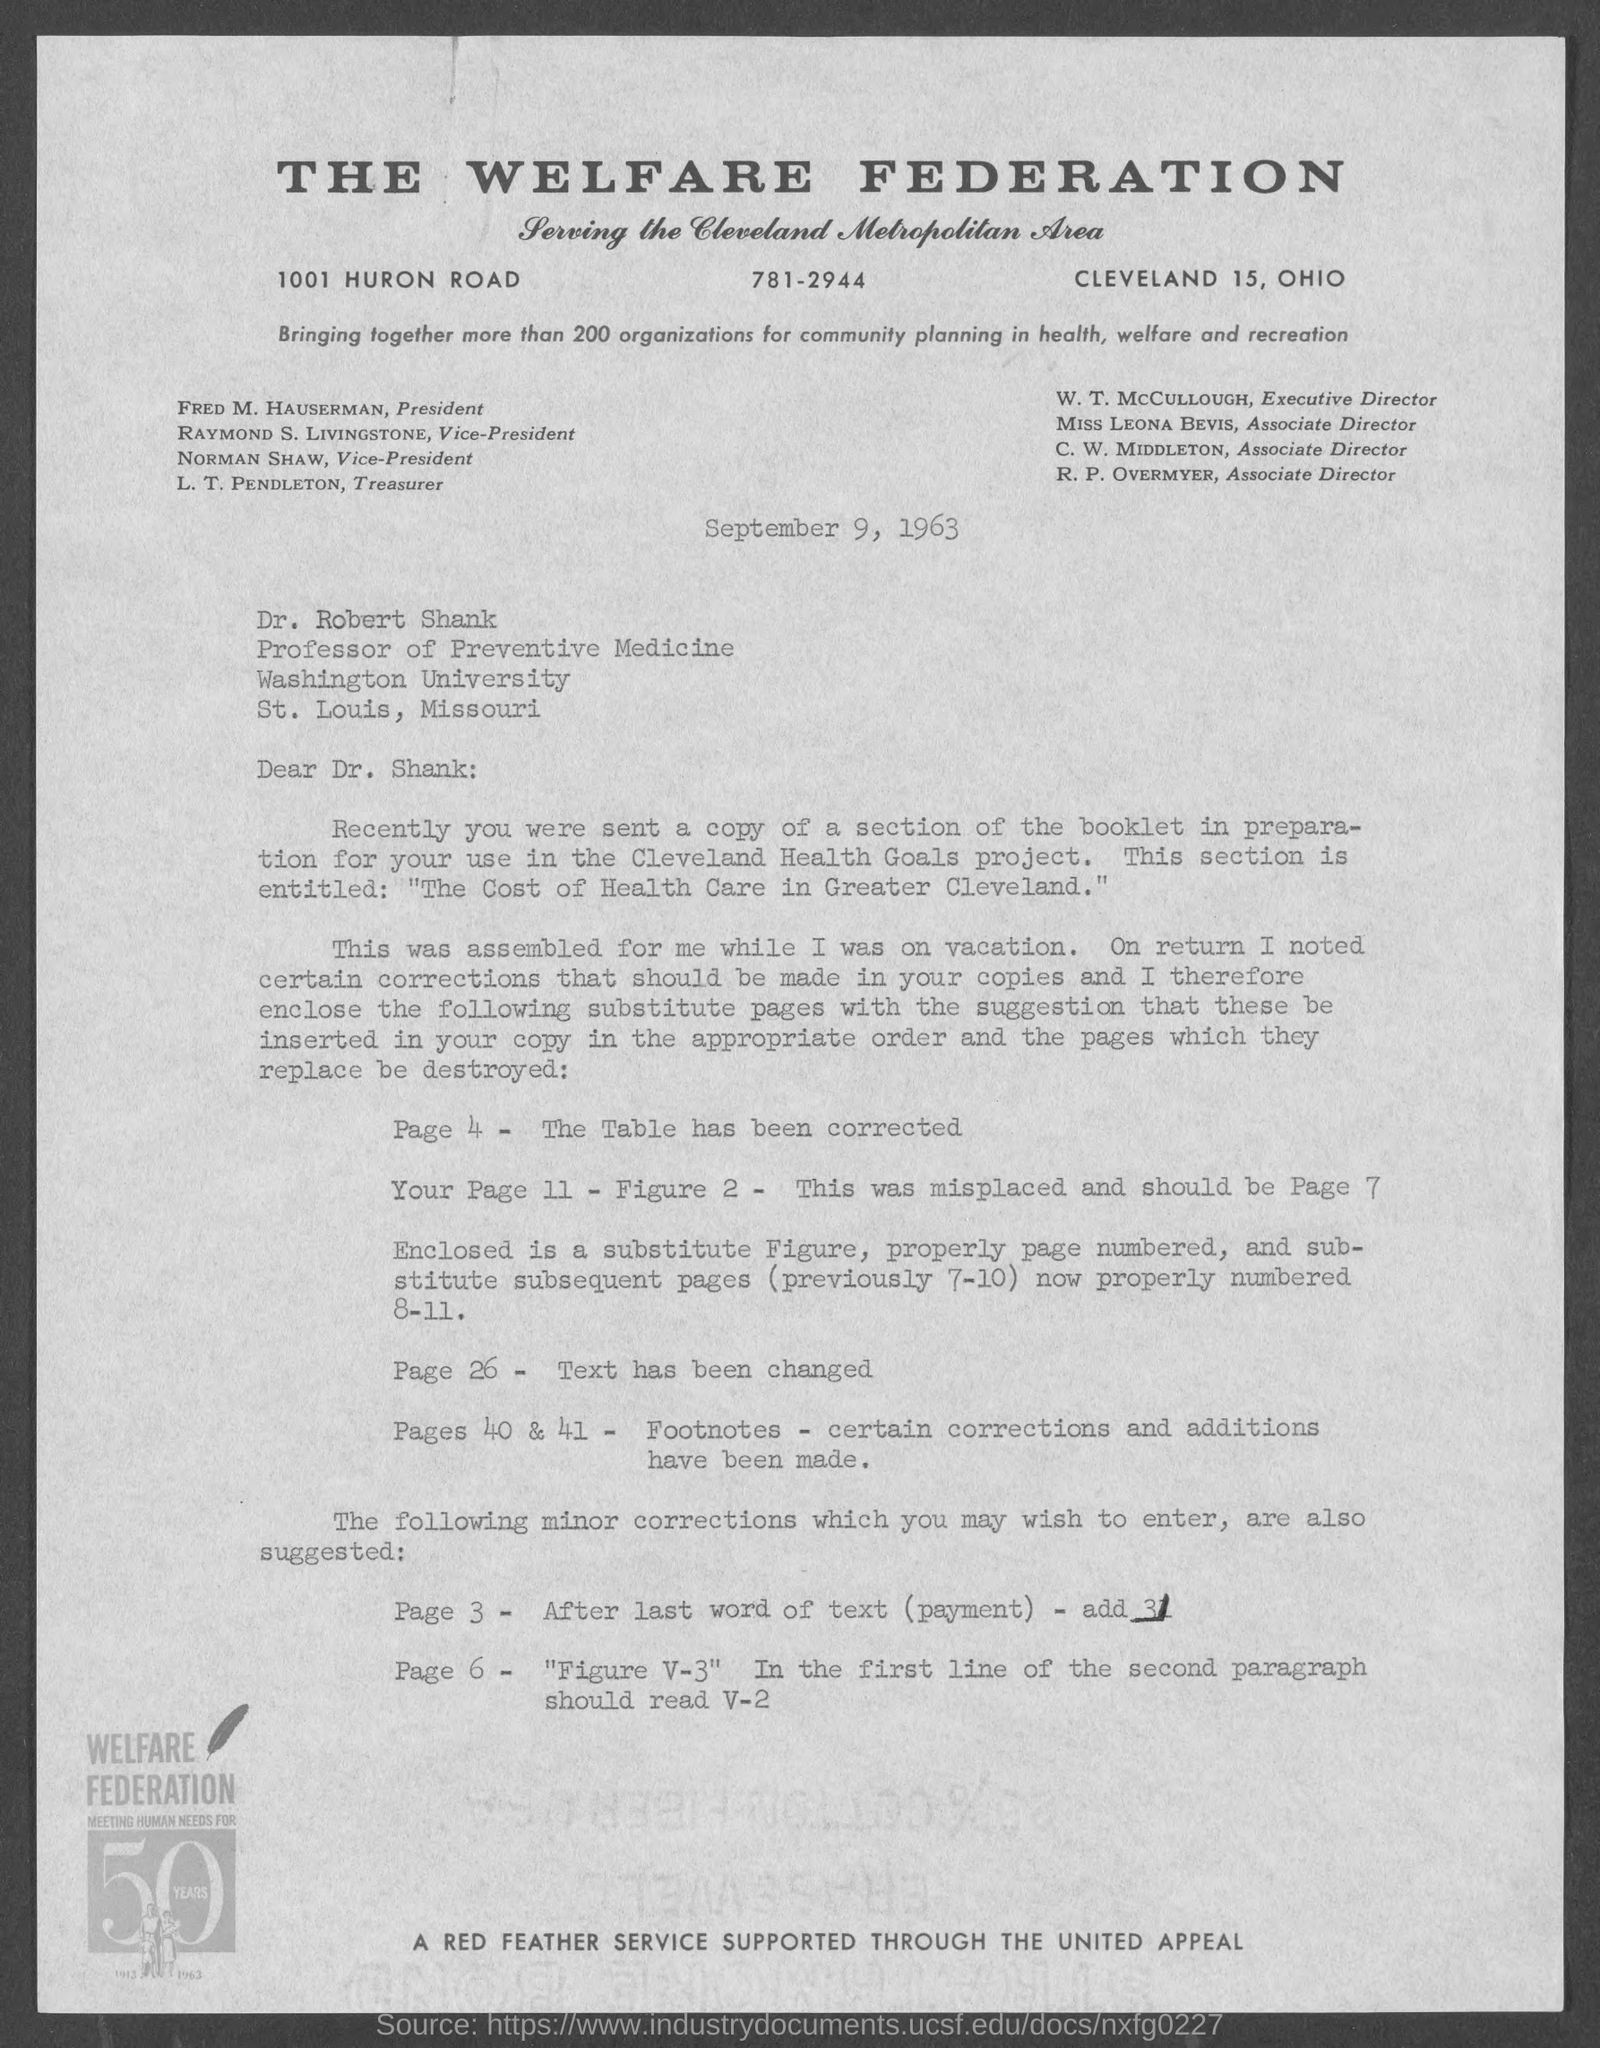What is the telephone number of the welfare federation ?
Give a very brief answer. 781-2944. Who is the president of the welfare federation ?
Your answer should be compact. Fred M. Hauserman. What is the position of dr. robert shank?
Offer a very short reply. Professor of Preventive Medicine. 